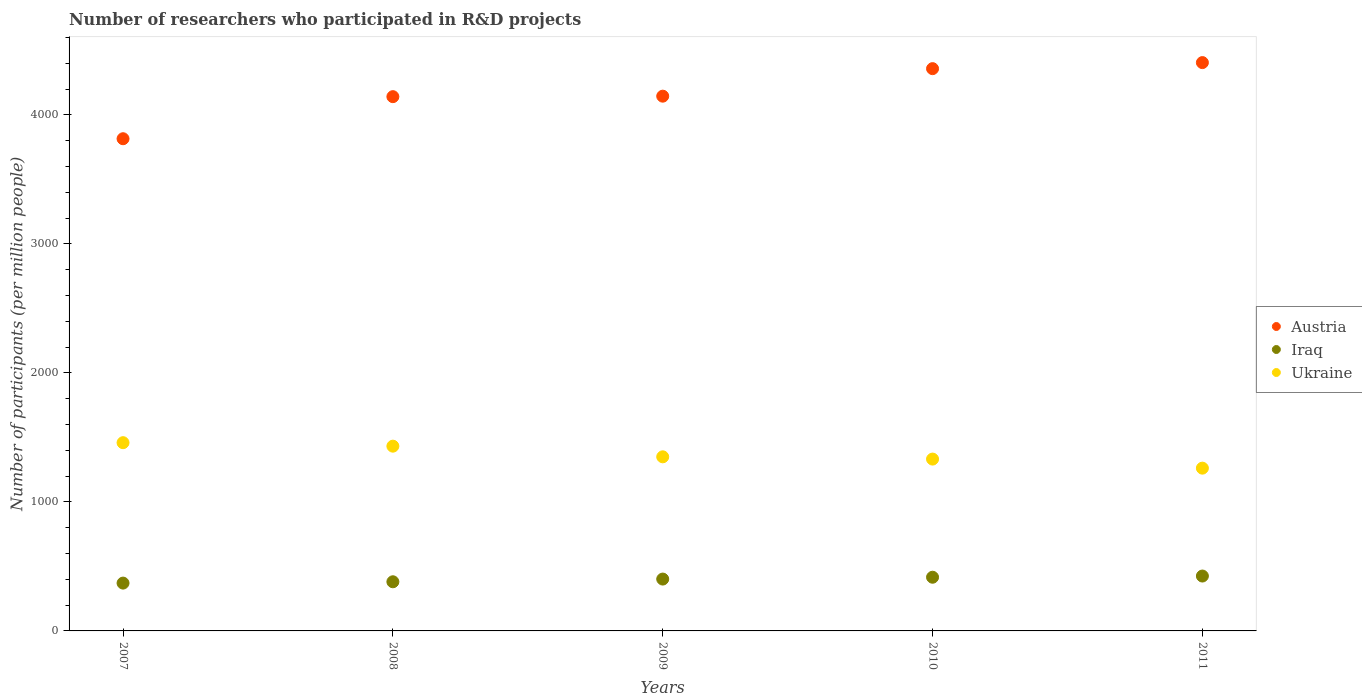How many different coloured dotlines are there?
Offer a very short reply. 3. What is the number of researchers who participated in R&D projects in Iraq in 2007?
Make the answer very short. 370.71. Across all years, what is the maximum number of researchers who participated in R&D projects in Ukraine?
Your answer should be compact. 1459.32. Across all years, what is the minimum number of researchers who participated in R&D projects in Austria?
Offer a terse response. 3815.74. In which year was the number of researchers who participated in R&D projects in Ukraine maximum?
Provide a short and direct response. 2007. In which year was the number of researchers who participated in R&D projects in Austria minimum?
Offer a very short reply. 2007. What is the total number of researchers who participated in R&D projects in Austria in the graph?
Your answer should be very brief. 2.09e+04. What is the difference between the number of researchers who participated in R&D projects in Iraq in 2007 and that in 2010?
Your answer should be compact. -45.54. What is the difference between the number of researchers who participated in R&D projects in Austria in 2011 and the number of researchers who participated in R&D projects in Iraq in 2007?
Provide a succinct answer. 4035.24. What is the average number of researchers who participated in R&D projects in Austria per year?
Make the answer very short. 4173.67. In the year 2007, what is the difference between the number of researchers who participated in R&D projects in Austria and number of researchers who participated in R&D projects in Ukraine?
Your answer should be compact. 2356.42. In how many years, is the number of researchers who participated in R&D projects in Ukraine greater than 1600?
Your answer should be very brief. 0. What is the ratio of the number of researchers who participated in R&D projects in Ukraine in 2008 to that in 2011?
Give a very brief answer. 1.14. What is the difference between the highest and the second highest number of researchers who participated in R&D projects in Iraq?
Give a very brief answer. 9.22. What is the difference between the highest and the lowest number of researchers who participated in R&D projects in Austria?
Offer a terse response. 590.21. In how many years, is the number of researchers who participated in R&D projects in Ukraine greater than the average number of researchers who participated in R&D projects in Ukraine taken over all years?
Your answer should be very brief. 2. Is the sum of the number of researchers who participated in R&D projects in Ukraine in 2008 and 2011 greater than the maximum number of researchers who participated in R&D projects in Iraq across all years?
Offer a very short reply. Yes. Does the number of researchers who participated in R&D projects in Ukraine monotonically increase over the years?
Your answer should be compact. No. Is the number of researchers who participated in R&D projects in Ukraine strictly greater than the number of researchers who participated in R&D projects in Iraq over the years?
Ensure brevity in your answer.  Yes. Is the number of researchers who participated in R&D projects in Iraq strictly less than the number of researchers who participated in R&D projects in Austria over the years?
Your answer should be very brief. Yes. How many dotlines are there?
Your answer should be very brief. 3. How many years are there in the graph?
Offer a very short reply. 5. Does the graph contain grids?
Ensure brevity in your answer.  No. How many legend labels are there?
Provide a short and direct response. 3. How are the legend labels stacked?
Ensure brevity in your answer.  Vertical. What is the title of the graph?
Your response must be concise. Number of researchers who participated in R&D projects. What is the label or title of the Y-axis?
Provide a succinct answer. Number of participants (per million people). What is the Number of participants (per million people) in Austria in 2007?
Your response must be concise. 3815.74. What is the Number of participants (per million people) in Iraq in 2007?
Provide a succinct answer. 370.71. What is the Number of participants (per million people) in Ukraine in 2007?
Provide a succinct answer. 1459.32. What is the Number of participants (per million people) of Austria in 2008?
Provide a short and direct response. 4141.92. What is the Number of participants (per million people) of Iraq in 2008?
Your answer should be compact. 381.03. What is the Number of participants (per million people) of Ukraine in 2008?
Your answer should be very brief. 1432.33. What is the Number of participants (per million people) of Austria in 2009?
Your answer should be compact. 4145.7. What is the Number of participants (per million people) in Iraq in 2009?
Provide a short and direct response. 401.99. What is the Number of participants (per million people) of Ukraine in 2009?
Your response must be concise. 1349.71. What is the Number of participants (per million people) of Austria in 2010?
Keep it short and to the point. 4359.03. What is the Number of participants (per million people) of Iraq in 2010?
Ensure brevity in your answer.  416.25. What is the Number of participants (per million people) of Ukraine in 2010?
Keep it short and to the point. 1332.2. What is the Number of participants (per million people) of Austria in 2011?
Give a very brief answer. 4405.95. What is the Number of participants (per million people) of Iraq in 2011?
Your answer should be very brief. 425.48. What is the Number of participants (per million people) in Ukraine in 2011?
Offer a very short reply. 1261.86. Across all years, what is the maximum Number of participants (per million people) of Austria?
Provide a succinct answer. 4405.95. Across all years, what is the maximum Number of participants (per million people) in Iraq?
Your response must be concise. 425.48. Across all years, what is the maximum Number of participants (per million people) in Ukraine?
Ensure brevity in your answer.  1459.32. Across all years, what is the minimum Number of participants (per million people) in Austria?
Your answer should be compact. 3815.74. Across all years, what is the minimum Number of participants (per million people) of Iraq?
Give a very brief answer. 370.71. Across all years, what is the minimum Number of participants (per million people) in Ukraine?
Make the answer very short. 1261.86. What is the total Number of participants (per million people) in Austria in the graph?
Offer a terse response. 2.09e+04. What is the total Number of participants (per million people) of Iraq in the graph?
Give a very brief answer. 1995.47. What is the total Number of participants (per million people) of Ukraine in the graph?
Offer a very short reply. 6835.42. What is the difference between the Number of participants (per million people) in Austria in 2007 and that in 2008?
Your response must be concise. -326.18. What is the difference between the Number of participants (per million people) of Iraq in 2007 and that in 2008?
Your response must be concise. -10.31. What is the difference between the Number of participants (per million people) of Ukraine in 2007 and that in 2008?
Provide a short and direct response. 26.99. What is the difference between the Number of participants (per million people) of Austria in 2007 and that in 2009?
Your answer should be compact. -329.96. What is the difference between the Number of participants (per million people) of Iraq in 2007 and that in 2009?
Your answer should be compact. -31.28. What is the difference between the Number of participants (per million people) of Ukraine in 2007 and that in 2009?
Ensure brevity in your answer.  109.61. What is the difference between the Number of participants (per million people) in Austria in 2007 and that in 2010?
Ensure brevity in your answer.  -543.28. What is the difference between the Number of participants (per million people) in Iraq in 2007 and that in 2010?
Make the answer very short. -45.54. What is the difference between the Number of participants (per million people) of Ukraine in 2007 and that in 2010?
Offer a terse response. 127.12. What is the difference between the Number of participants (per million people) of Austria in 2007 and that in 2011?
Your answer should be compact. -590.21. What is the difference between the Number of participants (per million people) in Iraq in 2007 and that in 2011?
Keep it short and to the point. -54.76. What is the difference between the Number of participants (per million people) of Ukraine in 2007 and that in 2011?
Provide a short and direct response. 197.46. What is the difference between the Number of participants (per million people) in Austria in 2008 and that in 2009?
Provide a succinct answer. -3.78. What is the difference between the Number of participants (per million people) in Iraq in 2008 and that in 2009?
Offer a terse response. -20.97. What is the difference between the Number of participants (per million people) in Ukraine in 2008 and that in 2009?
Give a very brief answer. 82.62. What is the difference between the Number of participants (per million people) in Austria in 2008 and that in 2010?
Ensure brevity in your answer.  -217.1. What is the difference between the Number of participants (per million people) of Iraq in 2008 and that in 2010?
Make the answer very short. -35.23. What is the difference between the Number of participants (per million people) in Ukraine in 2008 and that in 2010?
Offer a terse response. 100.13. What is the difference between the Number of participants (per million people) of Austria in 2008 and that in 2011?
Your answer should be compact. -264.03. What is the difference between the Number of participants (per million people) in Iraq in 2008 and that in 2011?
Your response must be concise. -44.45. What is the difference between the Number of participants (per million people) in Ukraine in 2008 and that in 2011?
Give a very brief answer. 170.47. What is the difference between the Number of participants (per million people) of Austria in 2009 and that in 2010?
Offer a terse response. -213.33. What is the difference between the Number of participants (per million people) of Iraq in 2009 and that in 2010?
Offer a very short reply. -14.26. What is the difference between the Number of participants (per million people) of Ukraine in 2009 and that in 2010?
Make the answer very short. 17.51. What is the difference between the Number of participants (per million people) of Austria in 2009 and that in 2011?
Offer a very short reply. -260.25. What is the difference between the Number of participants (per million people) of Iraq in 2009 and that in 2011?
Your answer should be very brief. -23.48. What is the difference between the Number of participants (per million people) in Ukraine in 2009 and that in 2011?
Your answer should be very brief. 87.85. What is the difference between the Number of participants (per million people) in Austria in 2010 and that in 2011?
Your answer should be very brief. -46.92. What is the difference between the Number of participants (per million people) of Iraq in 2010 and that in 2011?
Offer a terse response. -9.22. What is the difference between the Number of participants (per million people) of Ukraine in 2010 and that in 2011?
Make the answer very short. 70.34. What is the difference between the Number of participants (per million people) in Austria in 2007 and the Number of participants (per million people) in Iraq in 2008?
Provide a succinct answer. 3434.72. What is the difference between the Number of participants (per million people) in Austria in 2007 and the Number of participants (per million people) in Ukraine in 2008?
Offer a very short reply. 2383.42. What is the difference between the Number of participants (per million people) of Iraq in 2007 and the Number of participants (per million people) of Ukraine in 2008?
Your response must be concise. -1061.61. What is the difference between the Number of participants (per million people) of Austria in 2007 and the Number of participants (per million people) of Iraq in 2009?
Your answer should be compact. 3413.75. What is the difference between the Number of participants (per million people) in Austria in 2007 and the Number of participants (per million people) in Ukraine in 2009?
Provide a short and direct response. 2466.03. What is the difference between the Number of participants (per million people) in Iraq in 2007 and the Number of participants (per million people) in Ukraine in 2009?
Your answer should be very brief. -979. What is the difference between the Number of participants (per million people) in Austria in 2007 and the Number of participants (per million people) in Iraq in 2010?
Provide a short and direct response. 3399.49. What is the difference between the Number of participants (per million people) in Austria in 2007 and the Number of participants (per million people) in Ukraine in 2010?
Give a very brief answer. 2483.55. What is the difference between the Number of participants (per million people) in Iraq in 2007 and the Number of participants (per million people) in Ukraine in 2010?
Give a very brief answer. -961.48. What is the difference between the Number of participants (per million people) in Austria in 2007 and the Number of participants (per million people) in Iraq in 2011?
Keep it short and to the point. 3390.27. What is the difference between the Number of participants (per million people) in Austria in 2007 and the Number of participants (per million people) in Ukraine in 2011?
Offer a very short reply. 2553.88. What is the difference between the Number of participants (per million people) in Iraq in 2007 and the Number of participants (per million people) in Ukraine in 2011?
Provide a succinct answer. -891.15. What is the difference between the Number of participants (per million people) of Austria in 2008 and the Number of participants (per million people) of Iraq in 2009?
Provide a succinct answer. 3739.93. What is the difference between the Number of participants (per million people) of Austria in 2008 and the Number of participants (per million people) of Ukraine in 2009?
Make the answer very short. 2792.21. What is the difference between the Number of participants (per million people) of Iraq in 2008 and the Number of participants (per million people) of Ukraine in 2009?
Ensure brevity in your answer.  -968.68. What is the difference between the Number of participants (per million people) in Austria in 2008 and the Number of participants (per million people) in Iraq in 2010?
Provide a short and direct response. 3725.67. What is the difference between the Number of participants (per million people) in Austria in 2008 and the Number of participants (per million people) in Ukraine in 2010?
Give a very brief answer. 2809.73. What is the difference between the Number of participants (per million people) of Iraq in 2008 and the Number of participants (per million people) of Ukraine in 2010?
Provide a short and direct response. -951.17. What is the difference between the Number of participants (per million people) of Austria in 2008 and the Number of participants (per million people) of Iraq in 2011?
Your answer should be very brief. 3716.45. What is the difference between the Number of participants (per million people) in Austria in 2008 and the Number of participants (per million people) in Ukraine in 2011?
Your answer should be very brief. 2880.06. What is the difference between the Number of participants (per million people) of Iraq in 2008 and the Number of participants (per million people) of Ukraine in 2011?
Your answer should be very brief. -880.83. What is the difference between the Number of participants (per million people) of Austria in 2009 and the Number of participants (per million people) of Iraq in 2010?
Offer a terse response. 3729.45. What is the difference between the Number of participants (per million people) in Austria in 2009 and the Number of participants (per million people) in Ukraine in 2010?
Provide a succinct answer. 2813.5. What is the difference between the Number of participants (per million people) of Iraq in 2009 and the Number of participants (per million people) of Ukraine in 2010?
Offer a terse response. -930.2. What is the difference between the Number of participants (per million people) of Austria in 2009 and the Number of participants (per million people) of Iraq in 2011?
Provide a short and direct response. 3720.22. What is the difference between the Number of participants (per million people) in Austria in 2009 and the Number of participants (per million people) in Ukraine in 2011?
Offer a terse response. 2883.84. What is the difference between the Number of participants (per million people) in Iraq in 2009 and the Number of participants (per million people) in Ukraine in 2011?
Your answer should be very brief. -859.87. What is the difference between the Number of participants (per million people) in Austria in 2010 and the Number of participants (per million people) in Iraq in 2011?
Your response must be concise. 3933.55. What is the difference between the Number of participants (per million people) of Austria in 2010 and the Number of participants (per million people) of Ukraine in 2011?
Offer a terse response. 3097.17. What is the difference between the Number of participants (per million people) of Iraq in 2010 and the Number of participants (per million people) of Ukraine in 2011?
Offer a terse response. -845.61. What is the average Number of participants (per million people) of Austria per year?
Keep it short and to the point. 4173.67. What is the average Number of participants (per million people) in Iraq per year?
Offer a terse response. 399.09. What is the average Number of participants (per million people) in Ukraine per year?
Ensure brevity in your answer.  1367.08. In the year 2007, what is the difference between the Number of participants (per million people) of Austria and Number of participants (per million people) of Iraq?
Provide a short and direct response. 3445.03. In the year 2007, what is the difference between the Number of participants (per million people) of Austria and Number of participants (per million people) of Ukraine?
Offer a terse response. 2356.42. In the year 2007, what is the difference between the Number of participants (per million people) of Iraq and Number of participants (per million people) of Ukraine?
Provide a short and direct response. -1088.61. In the year 2008, what is the difference between the Number of participants (per million people) in Austria and Number of participants (per million people) in Iraq?
Keep it short and to the point. 3760.9. In the year 2008, what is the difference between the Number of participants (per million people) of Austria and Number of participants (per million people) of Ukraine?
Give a very brief answer. 2709.6. In the year 2008, what is the difference between the Number of participants (per million people) of Iraq and Number of participants (per million people) of Ukraine?
Provide a short and direct response. -1051.3. In the year 2009, what is the difference between the Number of participants (per million people) in Austria and Number of participants (per million people) in Iraq?
Your answer should be very brief. 3743.71. In the year 2009, what is the difference between the Number of participants (per million people) in Austria and Number of participants (per million people) in Ukraine?
Your response must be concise. 2795.99. In the year 2009, what is the difference between the Number of participants (per million people) of Iraq and Number of participants (per million people) of Ukraine?
Provide a short and direct response. -947.72. In the year 2010, what is the difference between the Number of participants (per million people) in Austria and Number of participants (per million people) in Iraq?
Keep it short and to the point. 3942.77. In the year 2010, what is the difference between the Number of participants (per million people) of Austria and Number of participants (per million people) of Ukraine?
Your response must be concise. 3026.83. In the year 2010, what is the difference between the Number of participants (per million people) of Iraq and Number of participants (per million people) of Ukraine?
Offer a very short reply. -915.94. In the year 2011, what is the difference between the Number of participants (per million people) of Austria and Number of participants (per million people) of Iraq?
Give a very brief answer. 3980.48. In the year 2011, what is the difference between the Number of participants (per million people) in Austria and Number of participants (per million people) in Ukraine?
Ensure brevity in your answer.  3144.09. In the year 2011, what is the difference between the Number of participants (per million people) in Iraq and Number of participants (per million people) in Ukraine?
Offer a terse response. -836.38. What is the ratio of the Number of participants (per million people) in Austria in 2007 to that in 2008?
Make the answer very short. 0.92. What is the ratio of the Number of participants (per million people) in Iraq in 2007 to that in 2008?
Your answer should be very brief. 0.97. What is the ratio of the Number of participants (per million people) in Ukraine in 2007 to that in 2008?
Provide a short and direct response. 1.02. What is the ratio of the Number of participants (per million people) of Austria in 2007 to that in 2009?
Ensure brevity in your answer.  0.92. What is the ratio of the Number of participants (per million people) in Iraq in 2007 to that in 2009?
Offer a very short reply. 0.92. What is the ratio of the Number of participants (per million people) in Ukraine in 2007 to that in 2009?
Provide a succinct answer. 1.08. What is the ratio of the Number of participants (per million people) in Austria in 2007 to that in 2010?
Ensure brevity in your answer.  0.88. What is the ratio of the Number of participants (per million people) in Iraq in 2007 to that in 2010?
Your answer should be very brief. 0.89. What is the ratio of the Number of participants (per million people) of Ukraine in 2007 to that in 2010?
Provide a succinct answer. 1.1. What is the ratio of the Number of participants (per million people) of Austria in 2007 to that in 2011?
Provide a short and direct response. 0.87. What is the ratio of the Number of participants (per million people) of Iraq in 2007 to that in 2011?
Your response must be concise. 0.87. What is the ratio of the Number of participants (per million people) in Ukraine in 2007 to that in 2011?
Make the answer very short. 1.16. What is the ratio of the Number of participants (per million people) of Austria in 2008 to that in 2009?
Keep it short and to the point. 1. What is the ratio of the Number of participants (per million people) in Iraq in 2008 to that in 2009?
Ensure brevity in your answer.  0.95. What is the ratio of the Number of participants (per million people) in Ukraine in 2008 to that in 2009?
Your answer should be compact. 1.06. What is the ratio of the Number of participants (per million people) in Austria in 2008 to that in 2010?
Provide a succinct answer. 0.95. What is the ratio of the Number of participants (per million people) in Iraq in 2008 to that in 2010?
Provide a succinct answer. 0.92. What is the ratio of the Number of participants (per million people) of Ukraine in 2008 to that in 2010?
Make the answer very short. 1.08. What is the ratio of the Number of participants (per million people) in Austria in 2008 to that in 2011?
Offer a very short reply. 0.94. What is the ratio of the Number of participants (per million people) of Iraq in 2008 to that in 2011?
Provide a short and direct response. 0.9. What is the ratio of the Number of participants (per million people) of Ukraine in 2008 to that in 2011?
Keep it short and to the point. 1.14. What is the ratio of the Number of participants (per million people) in Austria in 2009 to that in 2010?
Provide a short and direct response. 0.95. What is the ratio of the Number of participants (per million people) in Iraq in 2009 to that in 2010?
Your answer should be compact. 0.97. What is the ratio of the Number of participants (per million people) in Ukraine in 2009 to that in 2010?
Provide a succinct answer. 1.01. What is the ratio of the Number of participants (per million people) of Austria in 2009 to that in 2011?
Give a very brief answer. 0.94. What is the ratio of the Number of participants (per million people) of Iraq in 2009 to that in 2011?
Keep it short and to the point. 0.94. What is the ratio of the Number of participants (per million people) of Ukraine in 2009 to that in 2011?
Your response must be concise. 1.07. What is the ratio of the Number of participants (per million people) in Austria in 2010 to that in 2011?
Make the answer very short. 0.99. What is the ratio of the Number of participants (per million people) in Iraq in 2010 to that in 2011?
Provide a short and direct response. 0.98. What is the ratio of the Number of participants (per million people) in Ukraine in 2010 to that in 2011?
Give a very brief answer. 1.06. What is the difference between the highest and the second highest Number of participants (per million people) in Austria?
Give a very brief answer. 46.92. What is the difference between the highest and the second highest Number of participants (per million people) of Iraq?
Ensure brevity in your answer.  9.22. What is the difference between the highest and the second highest Number of participants (per million people) of Ukraine?
Your response must be concise. 26.99. What is the difference between the highest and the lowest Number of participants (per million people) of Austria?
Provide a short and direct response. 590.21. What is the difference between the highest and the lowest Number of participants (per million people) of Iraq?
Offer a terse response. 54.76. What is the difference between the highest and the lowest Number of participants (per million people) of Ukraine?
Provide a succinct answer. 197.46. 